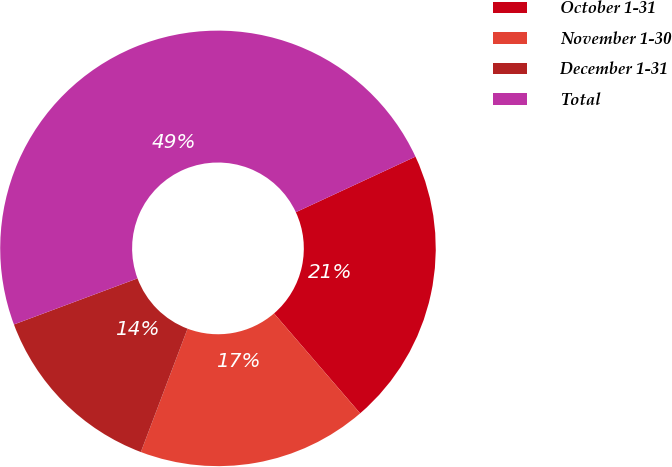Convert chart. <chart><loc_0><loc_0><loc_500><loc_500><pie_chart><fcel>October 1-31<fcel>November 1-30<fcel>December 1-31<fcel>Total<nl><fcel>20.6%<fcel>17.08%<fcel>13.56%<fcel>48.76%<nl></chart> 